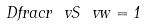Convert formula to latex. <formula><loc_0><loc_0><loc_500><loc_500>\ D f r a c r { \ v S } { \ v w } = 1</formula> 